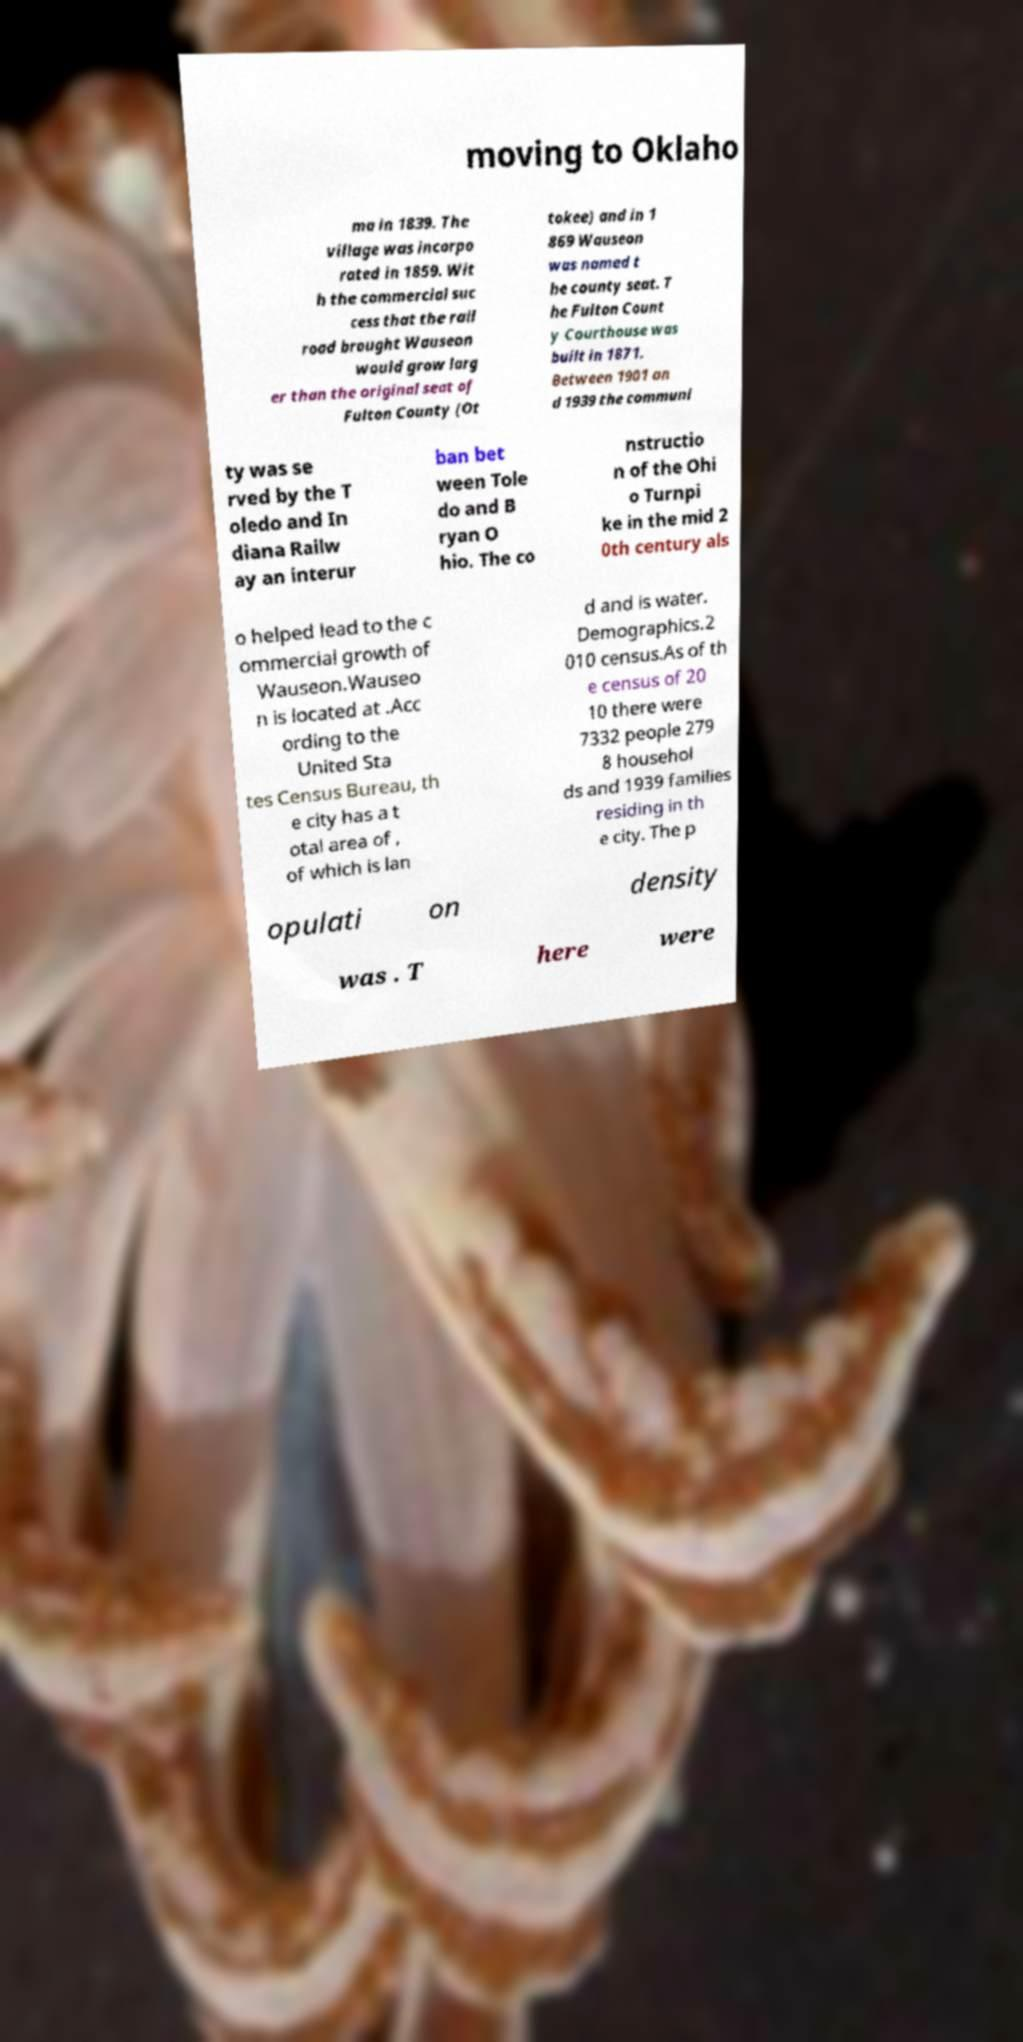Could you assist in decoding the text presented in this image and type it out clearly? moving to Oklaho ma in 1839. The village was incorpo rated in 1859. Wit h the commercial suc cess that the rail road brought Wauseon would grow larg er than the original seat of Fulton County (Ot tokee) and in 1 869 Wauseon was named t he county seat. T he Fulton Count y Courthouse was built in 1871. Between 1901 an d 1939 the communi ty was se rved by the T oledo and In diana Railw ay an interur ban bet ween Tole do and B ryan O hio. The co nstructio n of the Ohi o Turnpi ke in the mid 2 0th century als o helped lead to the c ommercial growth of Wauseon.Wauseo n is located at .Acc ording to the United Sta tes Census Bureau, th e city has a t otal area of , of which is lan d and is water. Demographics.2 010 census.As of th e census of 20 10 there were 7332 people 279 8 househol ds and 1939 families residing in th e city. The p opulati on density was . T here were 